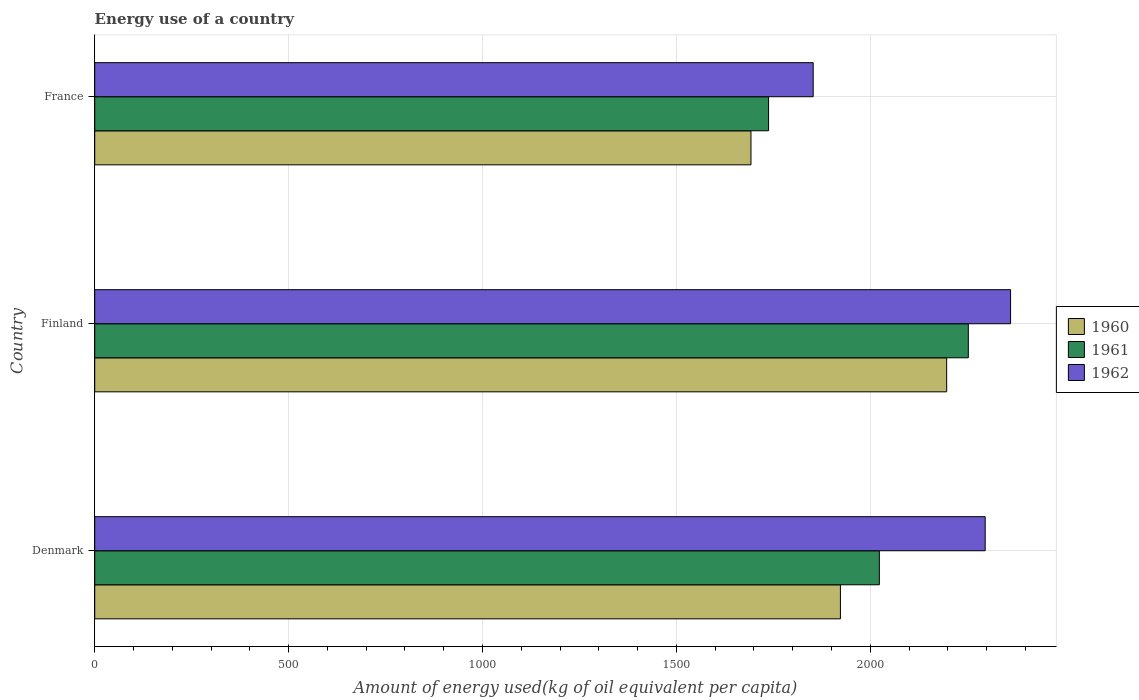Are the number of bars on each tick of the Y-axis equal?
Provide a succinct answer. Yes. How many bars are there on the 2nd tick from the bottom?
Offer a very short reply. 3. In how many cases, is the number of bars for a given country not equal to the number of legend labels?
Offer a terse response. 0. What is the amount of energy used in in 1961 in France?
Offer a terse response. 1737.69. Across all countries, what is the maximum amount of energy used in in 1961?
Keep it short and to the point. 2252.78. Across all countries, what is the minimum amount of energy used in in 1962?
Offer a very short reply. 1852.74. In which country was the amount of energy used in in 1961 maximum?
Make the answer very short. Finland. What is the total amount of energy used in in 1961 in the graph?
Ensure brevity in your answer.  6013.78. What is the difference between the amount of energy used in in 1960 in Finland and that in France?
Ensure brevity in your answer.  504.69. What is the difference between the amount of energy used in in 1961 in Denmark and the amount of energy used in in 1962 in France?
Keep it short and to the point. 170.57. What is the average amount of energy used in in 1961 per country?
Your answer should be compact. 2004.59. What is the difference between the amount of energy used in in 1960 and amount of energy used in in 1962 in France?
Your response must be concise. -160.47. What is the ratio of the amount of energy used in in 1961 in Finland to that in France?
Offer a very short reply. 1.3. Is the amount of energy used in in 1961 in Denmark less than that in France?
Your answer should be very brief. No. Is the difference between the amount of energy used in in 1960 in Denmark and Finland greater than the difference between the amount of energy used in in 1962 in Denmark and Finland?
Make the answer very short. No. What is the difference between the highest and the second highest amount of energy used in in 1960?
Ensure brevity in your answer.  273.98. What is the difference between the highest and the lowest amount of energy used in in 1961?
Give a very brief answer. 515.09. In how many countries, is the amount of energy used in in 1962 greater than the average amount of energy used in in 1962 taken over all countries?
Ensure brevity in your answer.  2. Is the sum of the amount of energy used in in 1962 in Denmark and Finland greater than the maximum amount of energy used in in 1961 across all countries?
Your answer should be compact. Yes. What does the 2nd bar from the top in Denmark represents?
Provide a succinct answer. 1961. What does the 3rd bar from the bottom in Finland represents?
Your answer should be compact. 1962. How many bars are there?
Offer a very short reply. 9. How many countries are there in the graph?
Keep it short and to the point. 3. What is the difference between two consecutive major ticks on the X-axis?
Your response must be concise. 500. Are the values on the major ticks of X-axis written in scientific E-notation?
Your response must be concise. No. Does the graph contain grids?
Provide a short and direct response. Yes. Where does the legend appear in the graph?
Provide a short and direct response. Center right. How many legend labels are there?
Offer a very short reply. 3. How are the legend labels stacked?
Give a very brief answer. Vertical. What is the title of the graph?
Make the answer very short. Energy use of a country. Does "1991" appear as one of the legend labels in the graph?
Keep it short and to the point. No. What is the label or title of the X-axis?
Provide a short and direct response. Amount of energy used(kg of oil equivalent per capita). What is the Amount of energy used(kg of oil equivalent per capita) of 1960 in Denmark?
Your response must be concise. 1922.97. What is the Amount of energy used(kg of oil equivalent per capita) in 1961 in Denmark?
Offer a terse response. 2023.31. What is the Amount of energy used(kg of oil equivalent per capita) of 1962 in Denmark?
Provide a succinct answer. 2296.29. What is the Amount of energy used(kg of oil equivalent per capita) in 1960 in Finland?
Keep it short and to the point. 2196.95. What is the Amount of energy used(kg of oil equivalent per capita) of 1961 in Finland?
Make the answer very short. 2252.78. What is the Amount of energy used(kg of oil equivalent per capita) in 1962 in Finland?
Your answer should be compact. 2361.74. What is the Amount of energy used(kg of oil equivalent per capita) of 1960 in France?
Ensure brevity in your answer.  1692.26. What is the Amount of energy used(kg of oil equivalent per capita) of 1961 in France?
Offer a terse response. 1737.69. What is the Amount of energy used(kg of oil equivalent per capita) of 1962 in France?
Your answer should be very brief. 1852.74. Across all countries, what is the maximum Amount of energy used(kg of oil equivalent per capita) in 1960?
Make the answer very short. 2196.95. Across all countries, what is the maximum Amount of energy used(kg of oil equivalent per capita) in 1961?
Your answer should be compact. 2252.78. Across all countries, what is the maximum Amount of energy used(kg of oil equivalent per capita) in 1962?
Your response must be concise. 2361.74. Across all countries, what is the minimum Amount of energy used(kg of oil equivalent per capita) in 1960?
Provide a short and direct response. 1692.26. Across all countries, what is the minimum Amount of energy used(kg of oil equivalent per capita) of 1961?
Your answer should be compact. 1737.69. Across all countries, what is the minimum Amount of energy used(kg of oil equivalent per capita) in 1962?
Keep it short and to the point. 1852.74. What is the total Amount of energy used(kg of oil equivalent per capita) in 1960 in the graph?
Make the answer very short. 5812.19. What is the total Amount of energy used(kg of oil equivalent per capita) of 1961 in the graph?
Give a very brief answer. 6013.78. What is the total Amount of energy used(kg of oil equivalent per capita) in 1962 in the graph?
Your answer should be compact. 6510.77. What is the difference between the Amount of energy used(kg of oil equivalent per capita) of 1960 in Denmark and that in Finland?
Your response must be concise. -273.98. What is the difference between the Amount of energy used(kg of oil equivalent per capita) in 1961 in Denmark and that in Finland?
Your answer should be compact. -229.47. What is the difference between the Amount of energy used(kg of oil equivalent per capita) in 1962 in Denmark and that in Finland?
Provide a succinct answer. -65.45. What is the difference between the Amount of energy used(kg of oil equivalent per capita) of 1960 in Denmark and that in France?
Provide a succinct answer. 230.71. What is the difference between the Amount of energy used(kg of oil equivalent per capita) in 1961 in Denmark and that in France?
Ensure brevity in your answer.  285.62. What is the difference between the Amount of energy used(kg of oil equivalent per capita) of 1962 in Denmark and that in France?
Make the answer very short. 443.55. What is the difference between the Amount of energy used(kg of oil equivalent per capita) in 1960 in Finland and that in France?
Offer a terse response. 504.69. What is the difference between the Amount of energy used(kg of oil equivalent per capita) of 1961 in Finland and that in France?
Make the answer very short. 515.09. What is the difference between the Amount of energy used(kg of oil equivalent per capita) in 1962 in Finland and that in France?
Keep it short and to the point. 509.01. What is the difference between the Amount of energy used(kg of oil equivalent per capita) in 1960 in Denmark and the Amount of energy used(kg of oil equivalent per capita) in 1961 in Finland?
Offer a very short reply. -329.81. What is the difference between the Amount of energy used(kg of oil equivalent per capita) of 1960 in Denmark and the Amount of energy used(kg of oil equivalent per capita) of 1962 in Finland?
Your answer should be very brief. -438.77. What is the difference between the Amount of energy used(kg of oil equivalent per capita) of 1961 in Denmark and the Amount of energy used(kg of oil equivalent per capita) of 1962 in Finland?
Provide a short and direct response. -338.44. What is the difference between the Amount of energy used(kg of oil equivalent per capita) in 1960 in Denmark and the Amount of energy used(kg of oil equivalent per capita) in 1961 in France?
Provide a short and direct response. 185.28. What is the difference between the Amount of energy used(kg of oil equivalent per capita) of 1960 in Denmark and the Amount of energy used(kg of oil equivalent per capita) of 1962 in France?
Your response must be concise. 70.24. What is the difference between the Amount of energy used(kg of oil equivalent per capita) in 1961 in Denmark and the Amount of energy used(kg of oil equivalent per capita) in 1962 in France?
Give a very brief answer. 170.57. What is the difference between the Amount of energy used(kg of oil equivalent per capita) of 1960 in Finland and the Amount of energy used(kg of oil equivalent per capita) of 1961 in France?
Keep it short and to the point. 459.26. What is the difference between the Amount of energy used(kg of oil equivalent per capita) in 1960 in Finland and the Amount of energy used(kg of oil equivalent per capita) in 1962 in France?
Make the answer very short. 344.22. What is the difference between the Amount of energy used(kg of oil equivalent per capita) in 1961 in Finland and the Amount of energy used(kg of oil equivalent per capita) in 1962 in France?
Your answer should be compact. 400.04. What is the average Amount of energy used(kg of oil equivalent per capita) in 1960 per country?
Ensure brevity in your answer.  1937.4. What is the average Amount of energy used(kg of oil equivalent per capita) in 1961 per country?
Provide a short and direct response. 2004.59. What is the average Amount of energy used(kg of oil equivalent per capita) in 1962 per country?
Your answer should be compact. 2170.26. What is the difference between the Amount of energy used(kg of oil equivalent per capita) in 1960 and Amount of energy used(kg of oil equivalent per capita) in 1961 in Denmark?
Ensure brevity in your answer.  -100.33. What is the difference between the Amount of energy used(kg of oil equivalent per capita) in 1960 and Amount of energy used(kg of oil equivalent per capita) in 1962 in Denmark?
Provide a succinct answer. -373.32. What is the difference between the Amount of energy used(kg of oil equivalent per capita) in 1961 and Amount of energy used(kg of oil equivalent per capita) in 1962 in Denmark?
Your answer should be very brief. -272.98. What is the difference between the Amount of energy used(kg of oil equivalent per capita) of 1960 and Amount of energy used(kg of oil equivalent per capita) of 1961 in Finland?
Ensure brevity in your answer.  -55.83. What is the difference between the Amount of energy used(kg of oil equivalent per capita) in 1960 and Amount of energy used(kg of oil equivalent per capita) in 1962 in Finland?
Provide a succinct answer. -164.79. What is the difference between the Amount of energy used(kg of oil equivalent per capita) of 1961 and Amount of energy used(kg of oil equivalent per capita) of 1962 in Finland?
Your answer should be very brief. -108.97. What is the difference between the Amount of energy used(kg of oil equivalent per capita) in 1960 and Amount of energy used(kg of oil equivalent per capita) in 1961 in France?
Keep it short and to the point. -45.43. What is the difference between the Amount of energy used(kg of oil equivalent per capita) in 1960 and Amount of energy used(kg of oil equivalent per capita) in 1962 in France?
Offer a very short reply. -160.47. What is the difference between the Amount of energy used(kg of oil equivalent per capita) in 1961 and Amount of energy used(kg of oil equivalent per capita) in 1962 in France?
Your answer should be compact. -115.05. What is the ratio of the Amount of energy used(kg of oil equivalent per capita) in 1960 in Denmark to that in Finland?
Your response must be concise. 0.88. What is the ratio of the Amount of energy used(kg of oil equivalent per capita) in 1961 in Denmark to that in Finland?
Your response must be concise. 0.9. What is the ratio of the Amount of energy used(kg of oil equivalent per capita) in 1962 in Denmark to that in Finland?
Make the answer very short. 0.97. What is the ratio of the Amount of energy used(kg of oil equivalent per capita) of 1960 in Denmark to that in France?
Your answer should be compact. 1.14. What is the ratio of the Amount of energy used(kg of oil equivalent per capita) in 1961 in Denmark to that in France?
Ensure brevity in your answer.  1.16. What is the ratio of the Amount of energy used(kg of oil equivalent per capita) of 1962 in Denmark to that in France?
Keep it short and to the point. 1.24. What is the ratio of the Amount of energy used(kg of oil equivalent per capita) of 1960 in Finland to that in France?
Ensure brevity in your answer.  1.3. What is the ratio of the Amount of energy used(kg of oil equivalent per capita) in 1961 in Finland to that in France?
Provide a succinct answer. 1.3. What is the ratio of the Amount of energy used(kg of oil equivalent per capita) of 1962 in Finland to that in France?
Your answer should be very brief. 1.27. What is the difference between the highest and the second highest Amount of energy used(kg of oil equivalent per capita) of 1960?
Your answer should be very brief. 273.98. What is the difference between the highest and the second highest Amount of energy used(kg of oil equivalent per capita) of 1961?
Your answer should be very brief. 229.47. What is the difference between the highest and the second highest Amount of energy used(kg of oil equivalent per capita) in 1962?
Your answer should be very brief. 65.45. What is the difference between the highest and the lowest Amount of energy used(kg of oil equivalent per capita) in 1960?
Ensure brevity in your answer.  504.69. What is the difference between the highest and the lowest Amount of energy used(kg of oil equivalent per capita) of 1961?
Your answer should be compact. 515.09. What is the difference between the highest and the lowest Amount of energy used(kg of oil equivalent per capita) in 1962?
Ensure brevity in your answer.  509.01. 